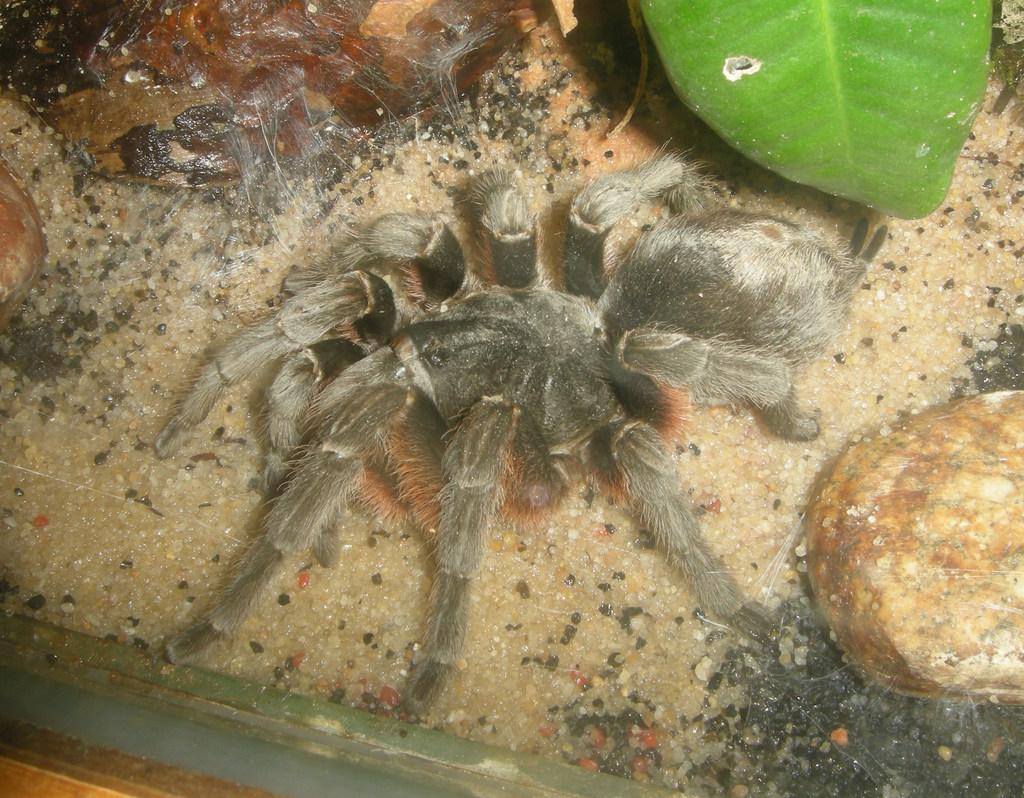What type of animal can be seen in the image? There is a spider in the image. Can you describe the color of the spider? The spider is black and ash colored. What other natural elements are present in the image? There is a rock and a green leaf in the image. Are there any other objects visible in the image? Yes, there are other objects visible in the image. What type of crack is the fireman trying to put out in the image? There is no fireman or crack present in the image; it features a spider, a rock, and a green leaf. 